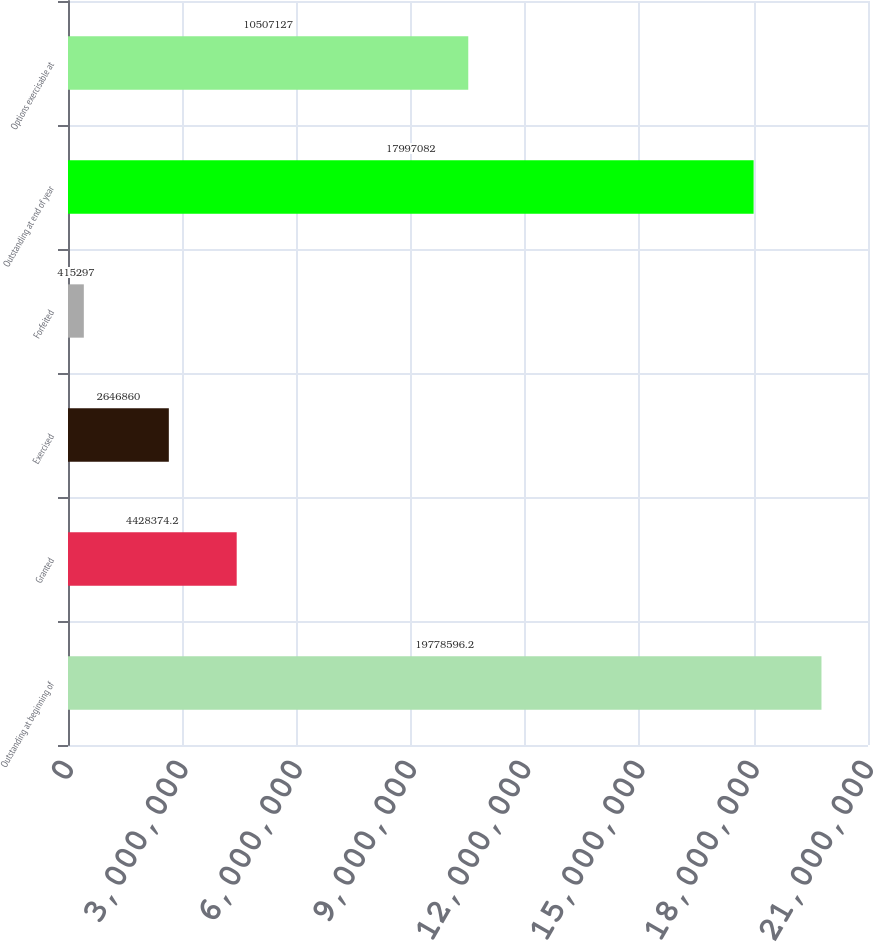Convert chart to OTSL. <chart><loc_0><loc_0><loc_500><loc_500><bar_chart><fcel>Outstanding at beginning of<fcel>Granted<fcel>Exercised<fcel>Forfeited<fcel>Outstanding at end of year<fcel>Options exercisable at<nl><fcel>1.97786e+07<fcel>4.42837e+06<fcel>2.64686e+06<fcel>415297<fcel>1.79971e+07<fcel>1.05071e+07<nl></chart> 